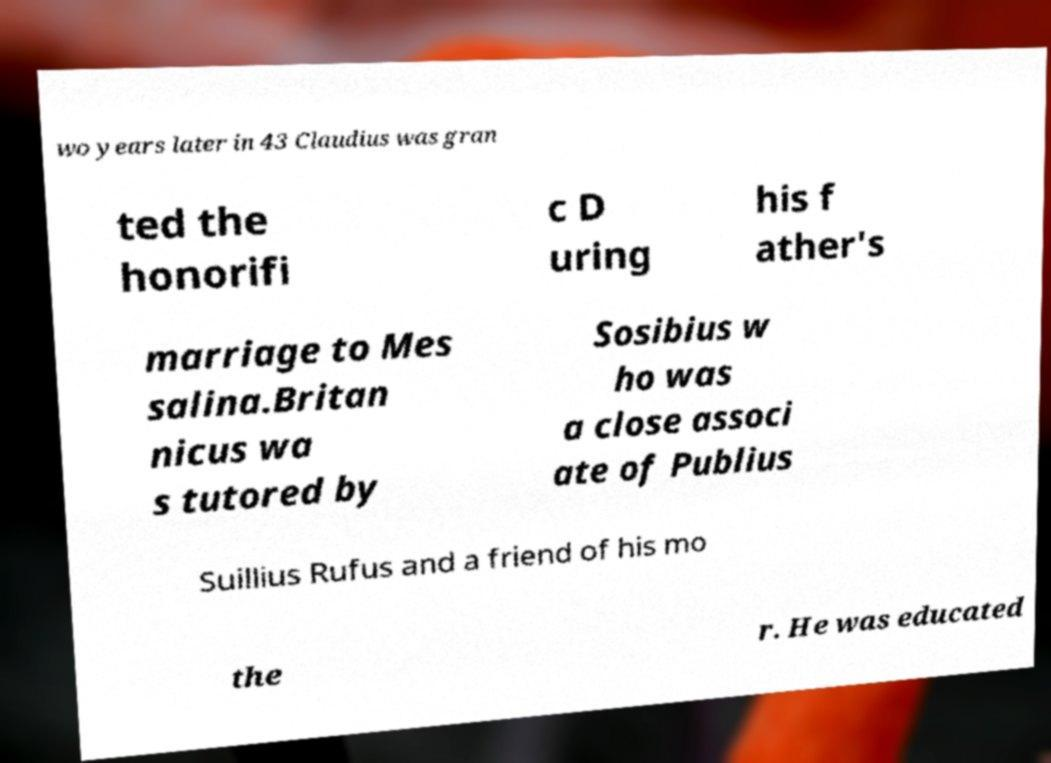What messages or text are displayed in this image? I need them in a readable, typed format. wo years later in 43 Claudius was gran ted the honorifi c D uring his f ather's marriage to Mes salina.Britan nicus wa s tutored by Sosibius w ho was a close associ ate of Publius Suillius Rufus and a friend of his mo the r. He was educated 